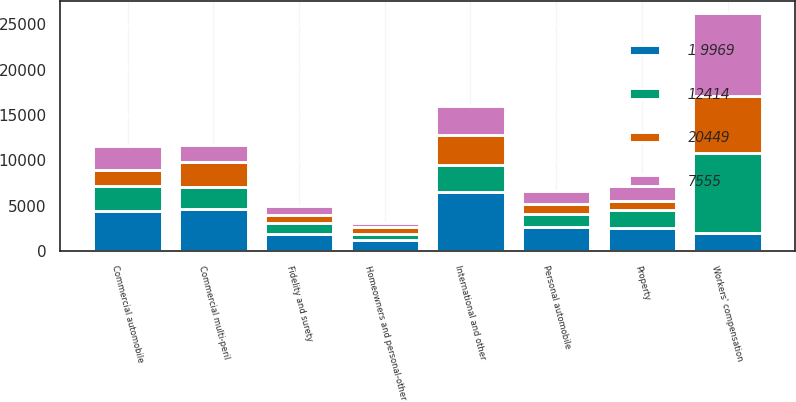Convert chart to OTSL. <chart><loc_0><loc_0><loc_500><loc_500><stacked_bar_chart><ecel><fcel>Property<fcel>Commercial multi-peril<fcel>Commercial automobile<fcel>Workers' compensation<fcel>Fidelity and surety<fcel>Personal automobile<fcel>Homeowners and personal-other<fcel>International and other<nl><fcel>7555<fcel>1612<fcel>1940<fcel>2573<fcel>9142<fcel>1035<fcel>1505<fcel>481<fcel>3296<nl><fcel>20449<fcel>978<fcel>2693<fcel>1801<fcel>6337<fcel>838<fcel>1092<fcel>706<fcel>3204<nl><fcel>1 9969<fcel>2590<fcel>4633<fcel>4374<fcel>1987<fcel>1873<fcel>2597<fcel>1187<fcel>6500<nl><fcel>12414<fcel>1987<fcel>2448<fcel>2792<fcel>8816<fcel>1240<fcel>1470<fcel>709<fcel>3033<nl></chart> 